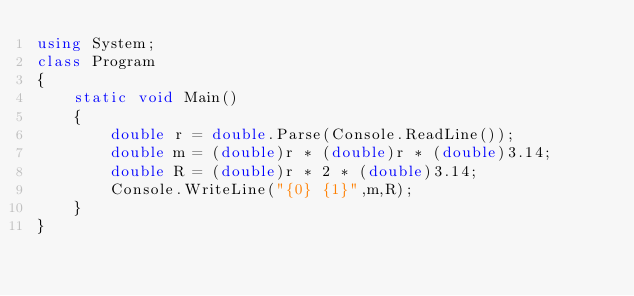Convert code to text. <code><loc_0><loc_0><loc_500><loc_500><_C#_>using System;
class Program
{
    static void Main()
    {
        double r = double.Parse(Console.ReadLine());
        double m = (double)r * (double)r * (double)3.14;
        double R = (double)r * 2 * (double)3.14;
        Console.WriteLine("{0} {1}",m,R);
    }
}</code> 